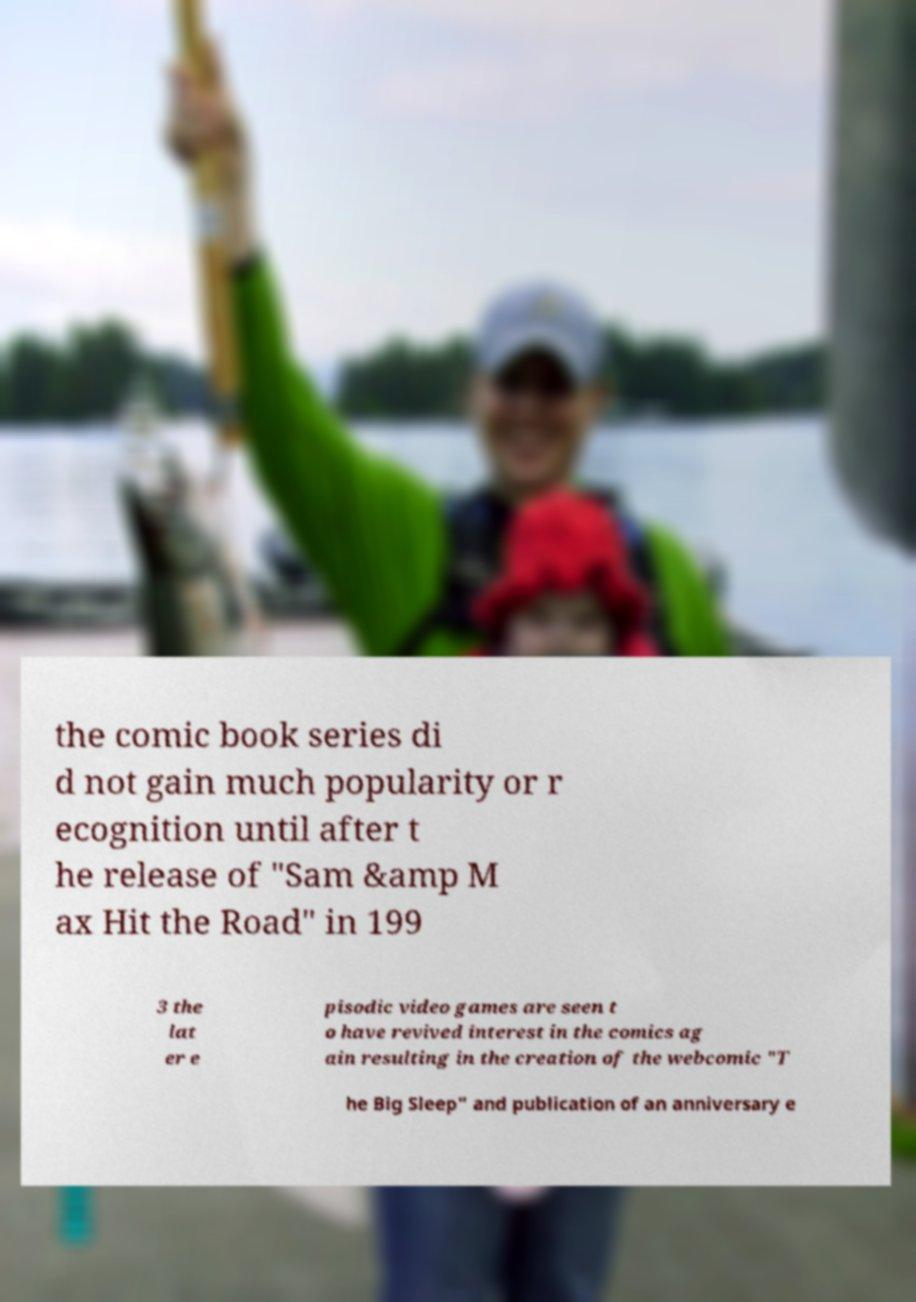Could you extract and type out the text from this image? the comic book series di d not gain much popularity or r ecognition until after t he release of "Sam &amp M ax Hit the Road" in 199 3 the lat er e pisodic video games are seen t o have revived interest in the comics ag ain resulting in the creation of the webcomic "T he Big Sleep" and publication of an anniversary e 